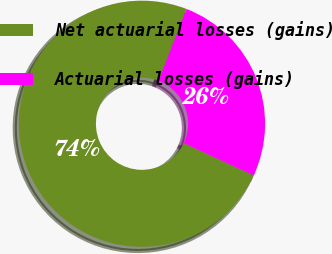Convert chart. <chart><loc_0><loc_0><loc_500><loc_500><pie_chart><fcel>Net actuarial losses (gains)<fcel>Actuarial losses (gains)<nl><fcel>73.99%<fcel>26.01%<nl></chart> 